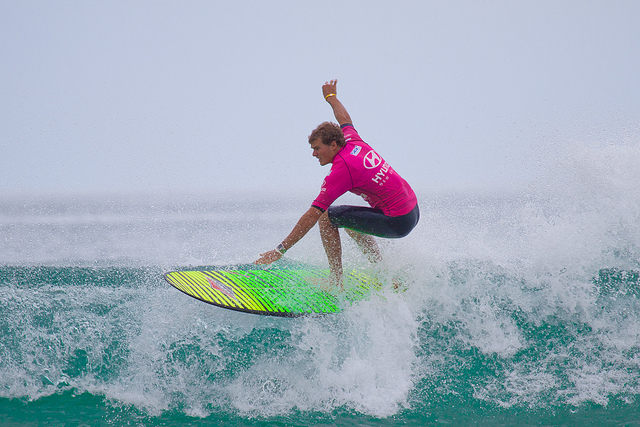Read and extract the text from this image. HYU 